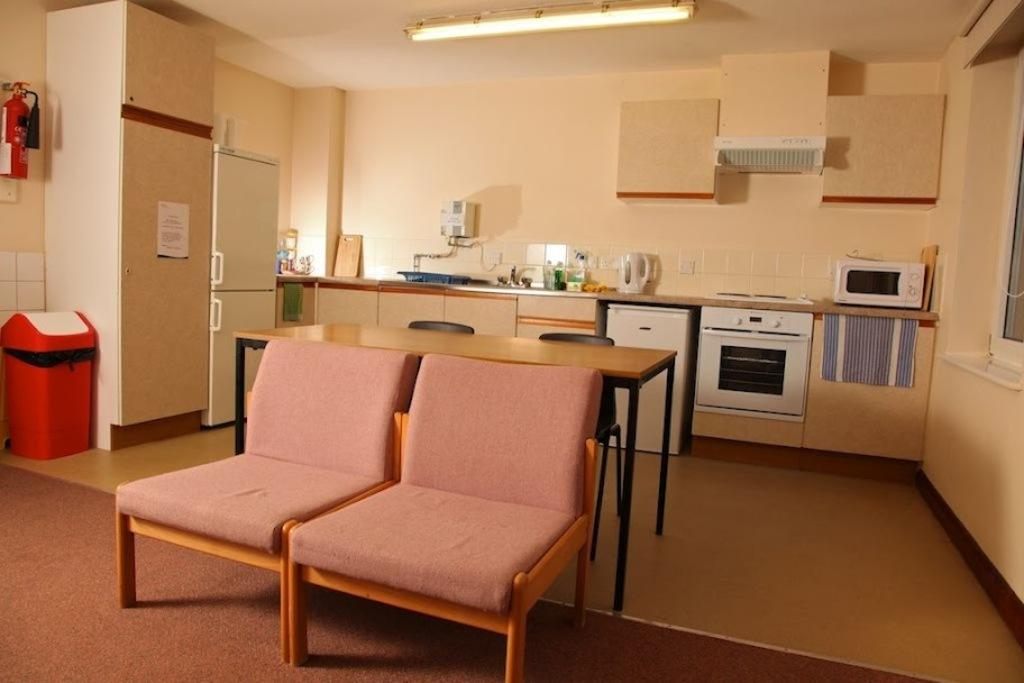What type of furniture is present in the image? There are chairs and a table in the image. What appliance can be seen in the image? There is a refrigerator in the image. What is used for waste disposal in the image? There is a dustbin in the image. What time of day is it in the image, and what type of coach can be seen? The time of day is not mentioned in the image, and there is no coach present in the image. 